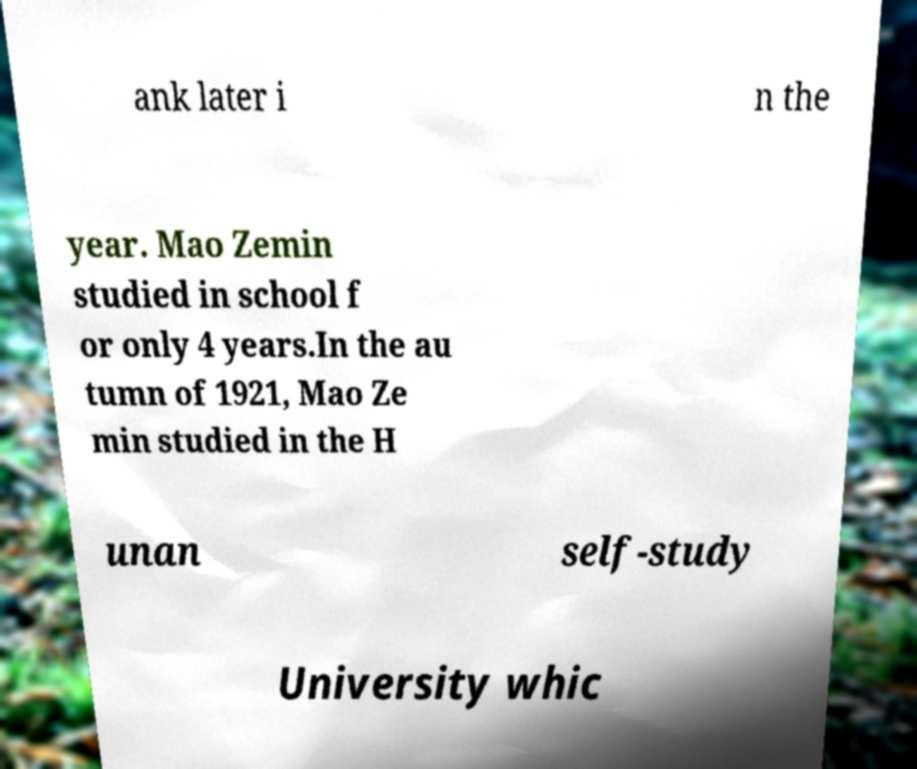For documentation purposes, I need the text within this image transcribed. Could you provide that? ank later i n the year. Mao Zemin studied in school f or only 4 years.In the au tumn of 1921, Mao Ze min studied in the H unan self-study University whic 